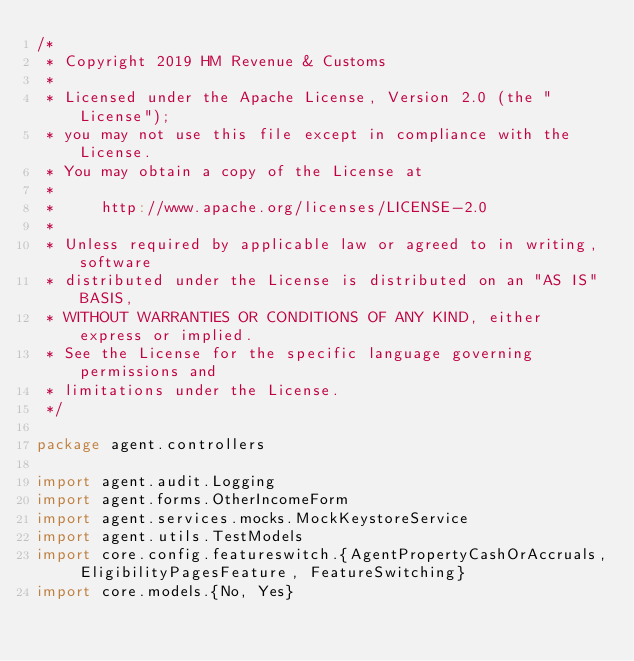<code> <loc_0><loc_0><loc_500><loc_500><_Scala_>/*
 * Copyright 2019 HM Revenue & Customs
 *
 * Licensed under the Apache License, Version 2.0 (the "License");
 * you may not use this file except in compliance with the License.
 * You may obtain a copy of the License at
 *
 *     http://www.apache.org/licenses/LICENSE-2.0
 *
 * Unless required by applicable law or agreed to in writing, software
 * distributed under the License is distributed on an "AS IS" BASIS,
 * WITHOUT WARRANTIES OR CONDITIONS OF ANY KIND, either express or implied.
 * See the License for the specific language governing permissions and
 * limitations under the License.
 */

package agent.controllers

import agent.audit.Logging
import agent.forms.OtherIncomeForm
import agent.services.mocks.MockKeystoreService
import agent.utils.TestModels
import core.config.featureswitch.{AgentPropertyCashOrAccruals, EligibilityPagesFeature, FeatureSwitching}
import core.models.{No, Yes}</code> 